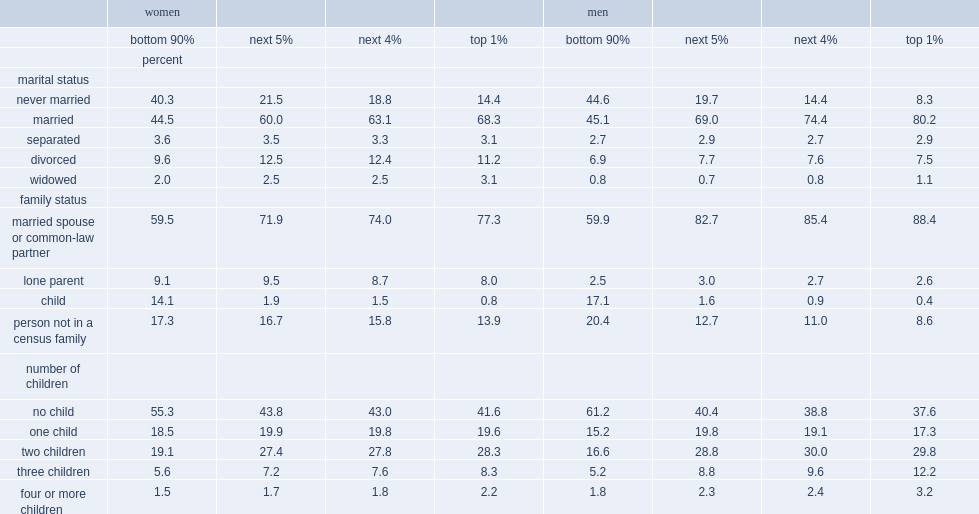Who were more likely to be married or in a common-law relationship,workers in the top 1% or those in the bottom 90%? Top 1%. What was the percentage of women and men in top 1% who were married or in a common-law relationship respectively? 77.3 88.4. What was the percentage of working women and men in the bottom 90% who were married or in a common-law relationship respectively? 59.5 59.9. What was the multiple relationship between women in top 1% who were lone parents and their male counterparts? 3.076923. For workers in the bottom 90%,who were more likely to be living alone or with non-family members,women or men? Men. What were the percentages of working women in the top 1% who were either living alone or with non-family members and their male counterparts respectively? 13.9 8.6. For workers in the top 1%,who were more likely to have one children? Women. For workers in the bottom 90%,who were more likely to have one children ,women or men? Women. What was the percentage of women in the top 1% who had no child and their male counterparts respectively? 41.6 37.6. For workers in the top 1%,who had fewer children,womem or men? Women. What was the percentage of women in the top 1% who had only one child and their male counterparts respectively? 19.6 17.3. What was the percentage of working men in the top 1% who had two or more children and their female counterparts respectively? 45.2 38.8. What was the percentage of men in top 1% who had three or more children and their female counterparts respectively? 15.4 10.5. 